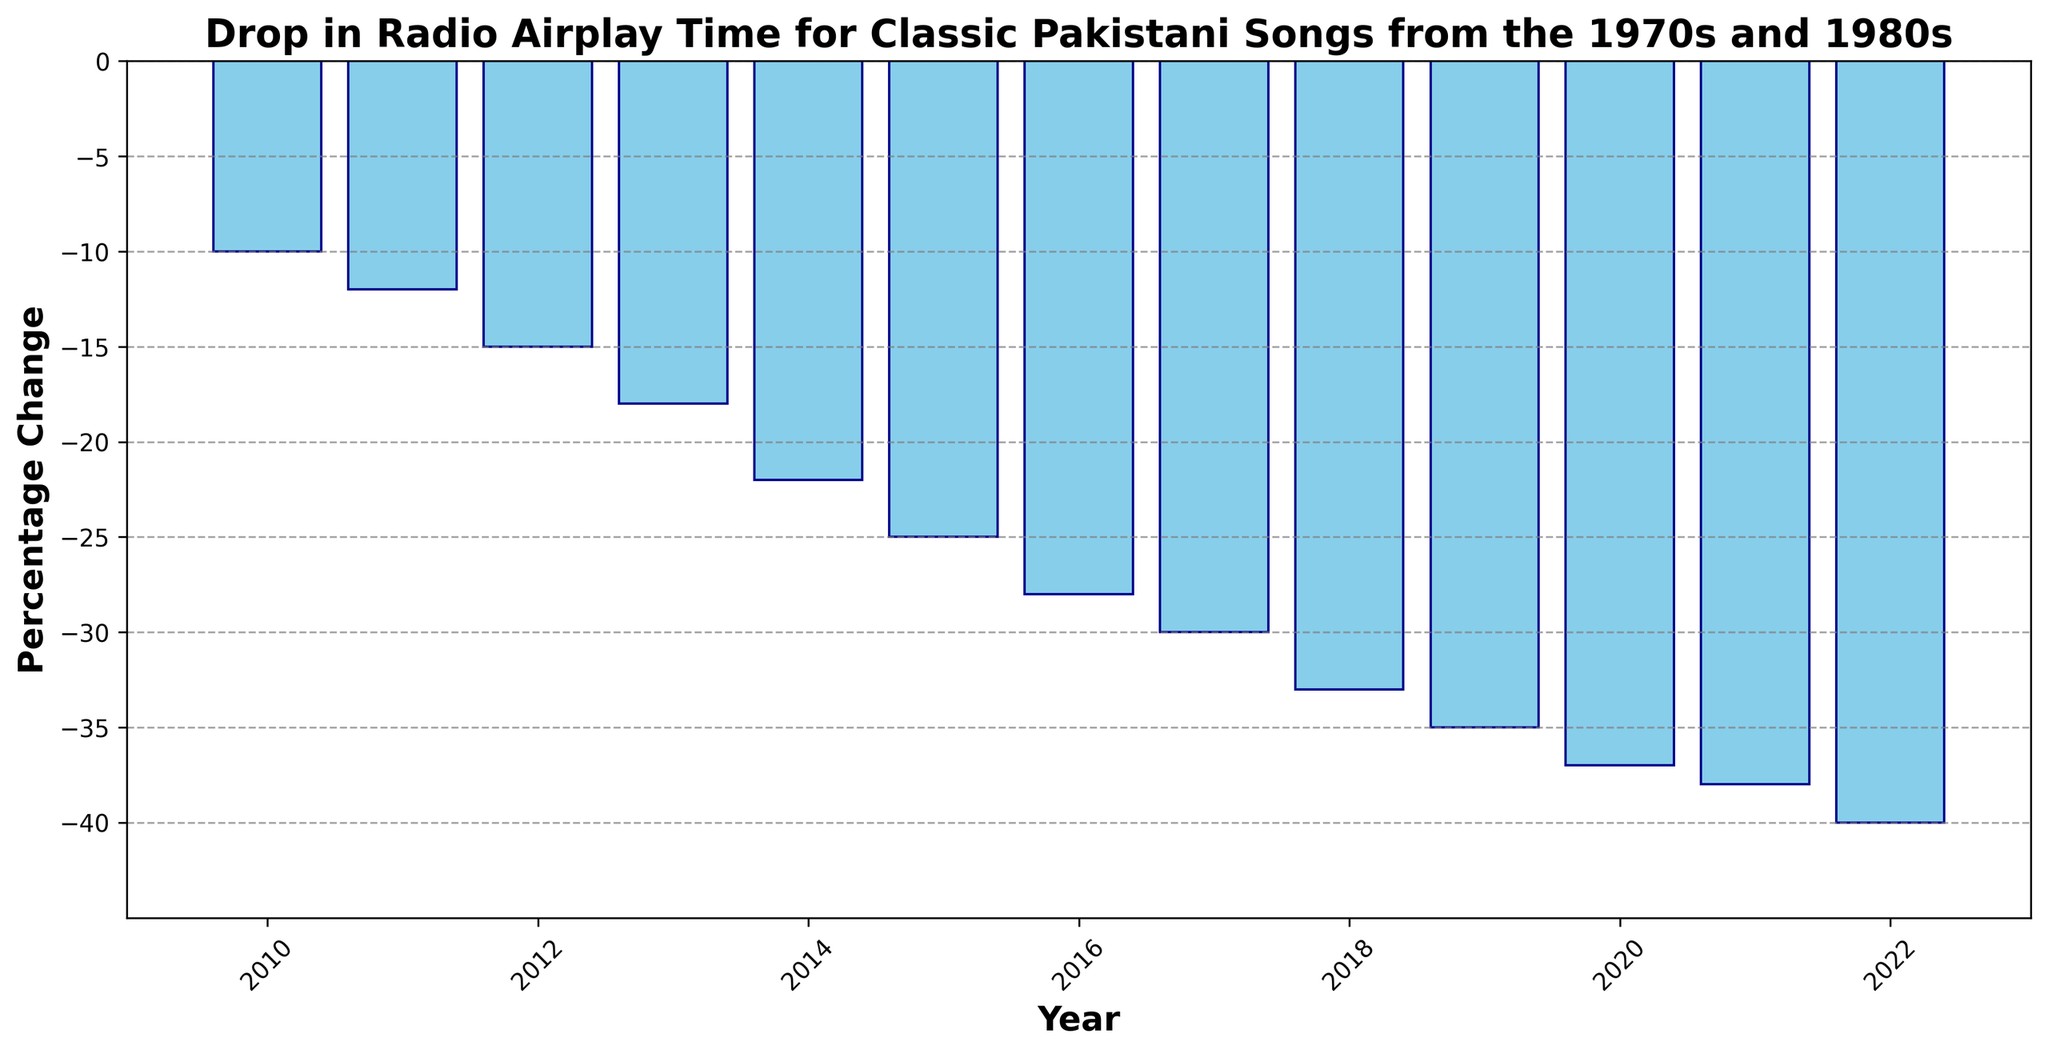What is the trend in the radio airplay time of classic Pakistani songs from 2010 to 2022? The figure shows a progressive decrease in the percentage change from -10% in 2010 to -40% in 2022. The bars consistently get longer towards the negative y-axis, indicating a steady drop.
Answer: Progressive decrease By how much did the percentage change in radio airplay time decrease between 2010 and 2015? In 2010, the percentage change was -10%, and in 2015, it was -25%. The difference between 2015 and 2010 is -25% - (-10%) = -15%.
Answer: -15% Which year had the steepest drop in radio airplay time compared to its previous year? Comparing year-over-year changes from the figure, the drop from 2014 (-22%) to 2015 (-25%) represents the steepest decline of -3% within one year.
Answer: 2015 How does the percentage change in 2016 compare to 2012? The percentage change in 2016 is -28%, while in 2012 it is -15%. Thus, 2016 has -28% - (-15%) = -13% more decrease in radio airplay time than 2012.
Answer: -13% more Between which two consecutive years did the percentage change in radio airplay time remain the same? By looking at the figure, we see that the most similar bars in height are those of 2020 (-37%) and 2021 (-38%), but no two consecutive years have an identical percentage change.
Answer: None What is the overall percentage decrease in radio airplay time from 2010 to 2022? The overall decrease from 2010 to 2022 can be found by subtracting the percentage change in 2010 from that in 2022: -40% - (-10%) = -30%.
Answer: -30% How does the percentage change in 2018 compare visually to that in 2017? In 2018, the percentage change is -33%, and in 2017, it is -30%. The height of the bar for 2018 is slightly longer than that of 2017, indicating an additional -3% decrease.
Answer: -3% If you average the percentage changes from 2010 to 2014, what would be the result? The sum of the percentage changes from 2010 to 2014 is -10% -12% -15% -18% -22% = -77%. Dividing by the 5 years: -77% / 5 = -15.4%.
Answer: -15.4% By how much did the radio airplay time percentage change from 2019 to 2022? In 2019, the percentage change is -35%, and in 2022, it is -40%. The difference is -40% - (-35%) = -5%.
Answer: -5% Was there any year when the percentage change stabilized or slowed down significantly, and if so, which year? While no year shows a complete stabilization, the drop from 2021 (-38%) to 2022 (-40%) shows the smallest change of only -2%, indicating a slowed decrease.
Answer: 2022 